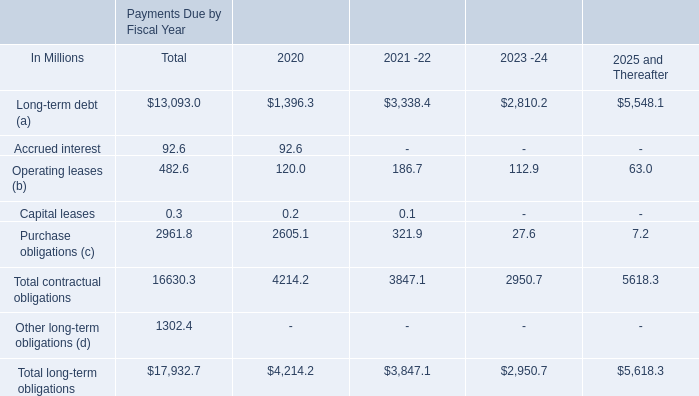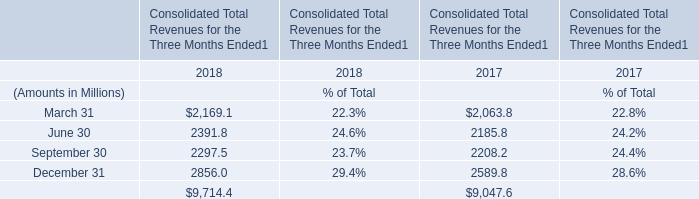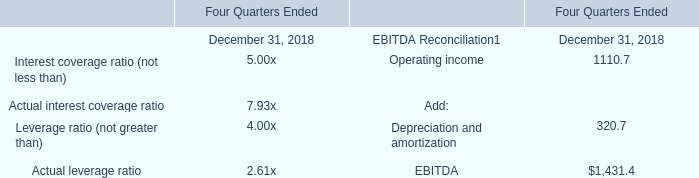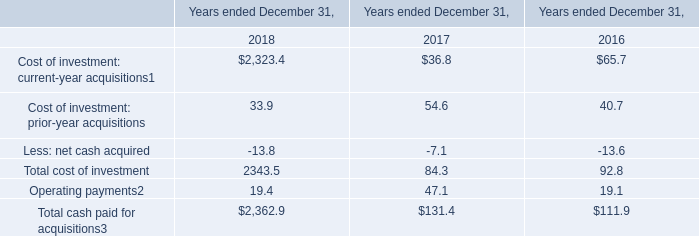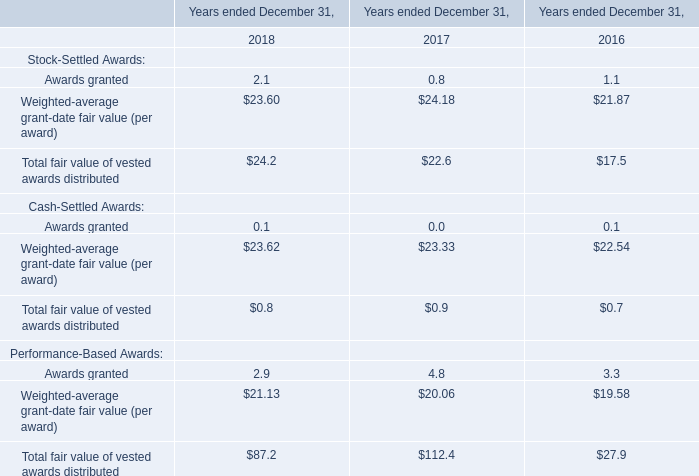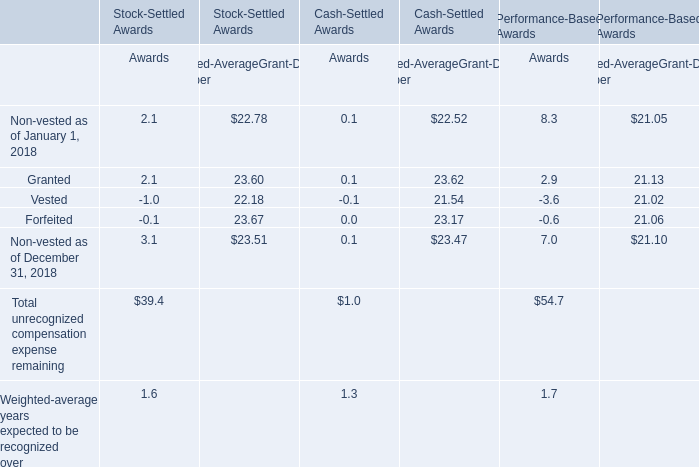What is the growing rate of Total fair value of vested awards distributed in the year with the most Awards granted? 
Computations: ((24.2 - 22.6) / 22.6)
Answer: 0.0708. 